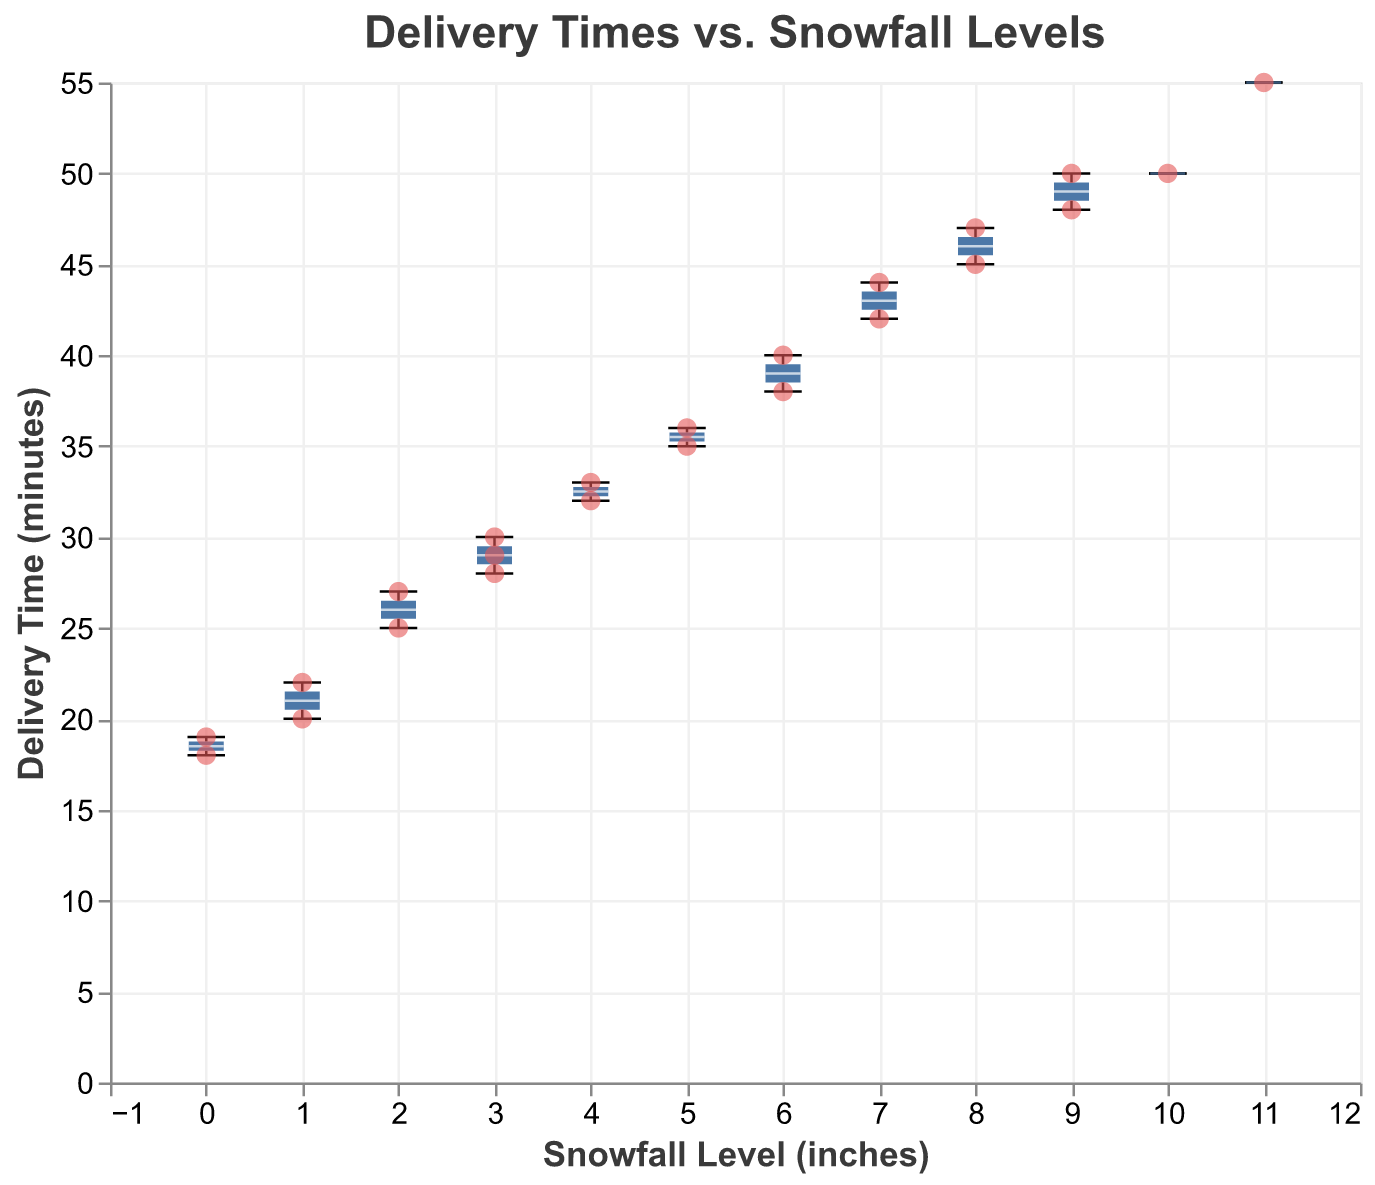What is the title of the figure? The title of the figure is displayed at the top and reads "Delivery Times vs. Snowfall Levels".
Answer: Delivery Times vs. Snowfall Levels What does the y-axis represent? The y-axis represents "Delivery Time" and is measured in "minutes". This can be seen from the y-axis label on the left side of the chart.
Answer: Delivery Time (minutes) How many data points are plotted in total? Each delivery date has one associated data point. By counting the data points within the scatter plot, we see that there are 22 data points.
Answer: 22 What is the median delivery time for days with 3 inches of snowfall? To find the median delivery time, locate the box corresponding to the snowfall level of 3 inches and identify the white median line within the box. The median delivery time is around 29 minutes.
Answer: 29 minutes Which snowfall level has the widest range of delivery times? The range of delivery times can be determined by looking at the length of the box plot whiskers. The box plot for 11 inches of snowfall shows the widest range, extending from approximately 45 minutes to 55 minutes.
Answer: 11 inches What is the lowest recorded delivery time, and at what snowfall level does it occur? The scatter plot displays individual data points. The lowest delivery time is 18 minutes, which occurs at a snowfall level of 0 inches.
Answer: 18 minutes at 0 inches Is there a noticeable trend between snowfall levels and delivery times? By examining the scatter points and box plots, it appears that higher snowfall levels are generally associated with longer delivery times, indicating a positive correlation.
Answer: Higher snowfall levels are associated with longer delivery times What is the delivery time on 2023-02-10, and what is the snowfall level on that day? Locate the specific date 2023-02-10 within the data points. The delivery time on this date is 55 minutes, with a snowfall level of 11 inches.
Answer: 55 minutes with 11 inches of snowfall Are there any outliers in delivery times when snowfall is at 4 inches? Outliers in box plots are typically marked as individual points outside the whiskers. For 4 inches of snowfall, there are no outliers marked; all data points fall within the whiskers.
Answer: No Does the snowfall level of 8 inches have any delivery times over 45 minutes? Look at the scatter plot points corresponding to 8 inches of snowfall. The points indicate delivery times of 45 and 47 minutes, both are over 45.
Answer: Yes 